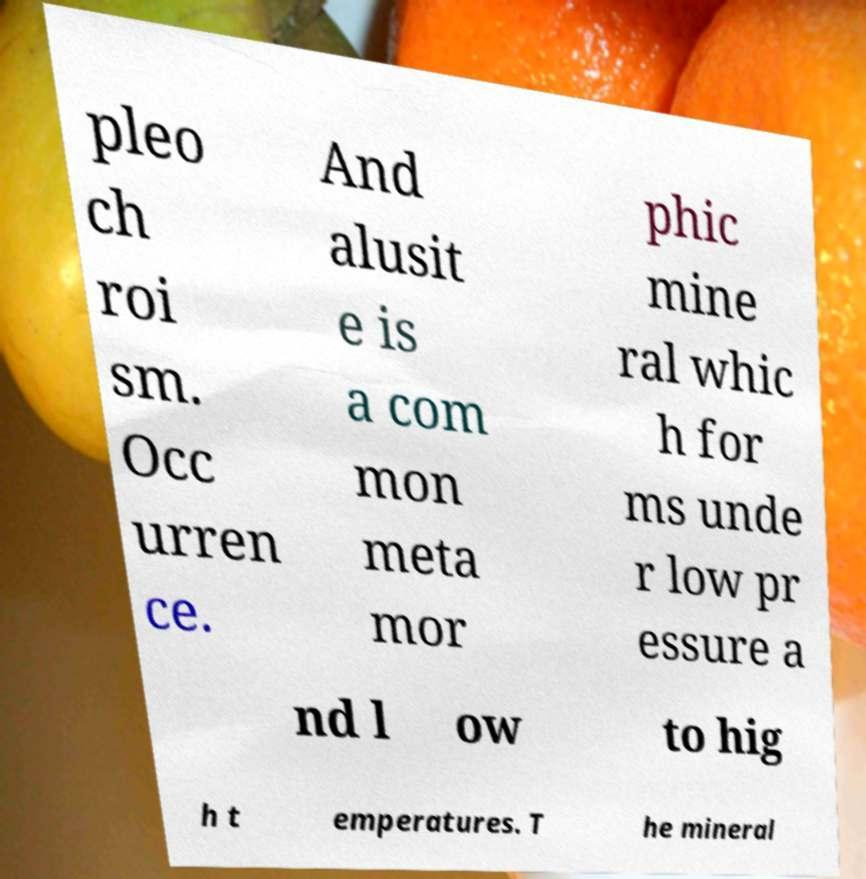There's text embedded in this image that I need extracted. Can you transcribe it verbatim? pleo ch roi sm. Occ urren ce. And alusit e is a com mon meta mor phic mine ral whic h for ms unde r low pr essure a nd l ow to hig h t emperatures. T he mineral 